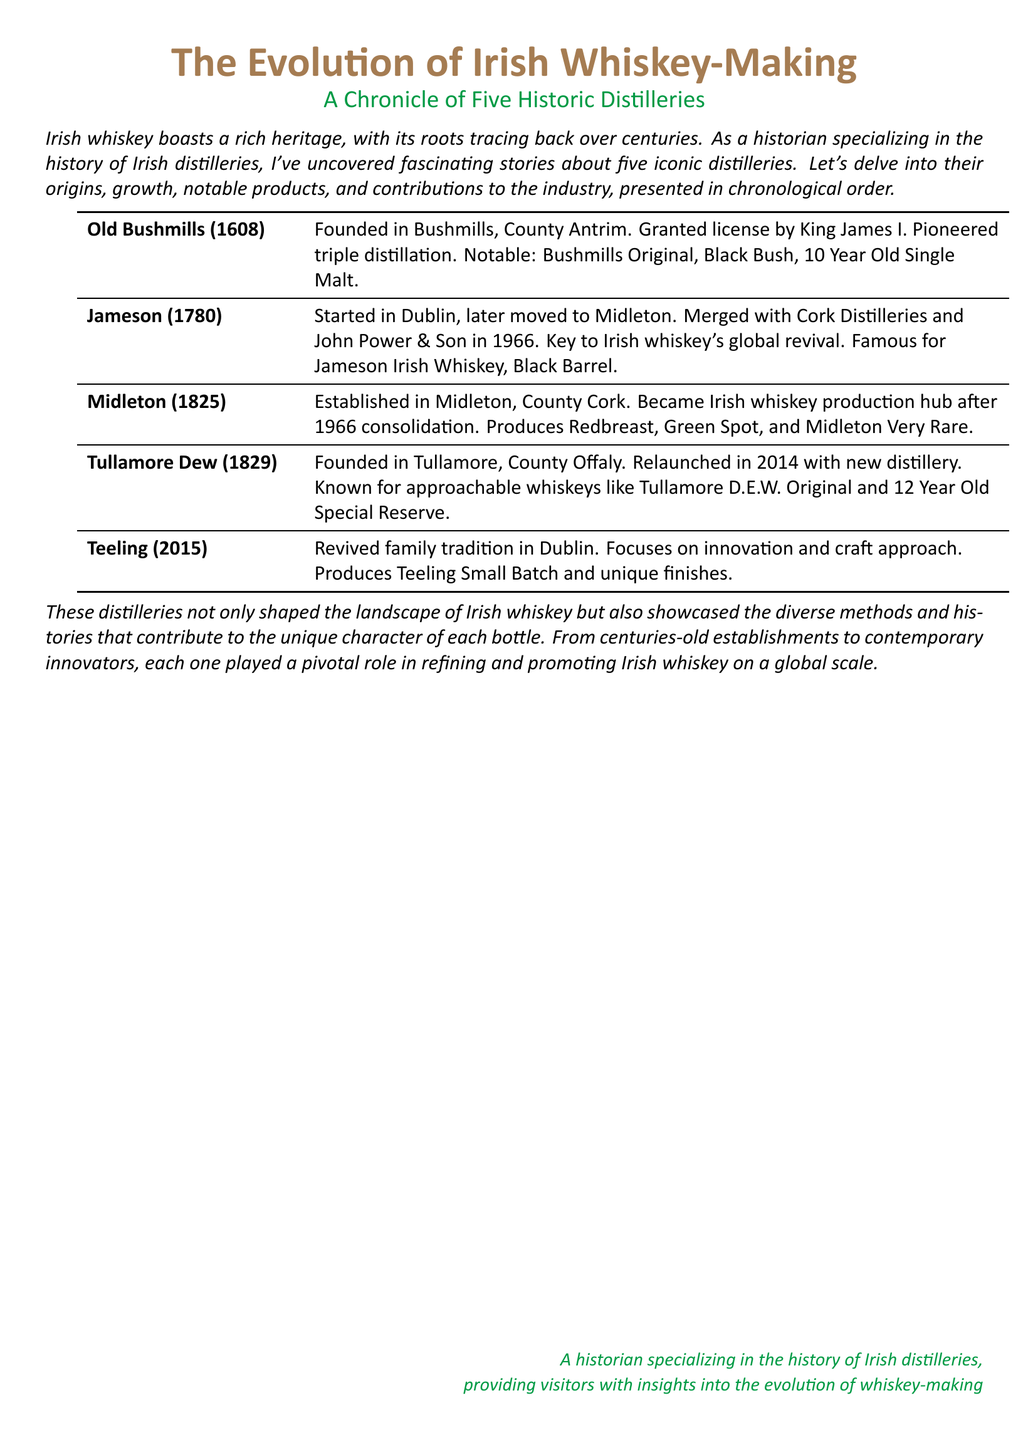What year was Old Bushmills founded? Old Bushmills was founded in the year 1608 as stated in the document.
Answer: 1608 Which distillery is known for the product Black Bush? The document indicates that Black Bush is one of the notable products from Old Bushmills.
Answer: Old Bushmills What year was Jameson established? According to the document, Jameson was established in 1780.
Answer: 1780 What are two notable products from Midleton? The document lists Redbreast and Green Spot as notable products from Midleton.
Answer: Redbreast, Green Spot Which distillery relaunched in 2014? The document mentions Tullamore Dew as the distillery that was relaunched in 2014.
Answer: Tullamore Dew How many years after Old Bushmills was Teeling founded? Teeling was founded in 2015, which is 407 years after Old Bushmills (founded in 1608).
Answer: 407 years What is a key contribution of Jameson to the whiskey industry? The document highlights that Jameson was key to the global revival of Irish whiskey.
Answer: Global revival Which distillery is associated with the town of Tullamore? Tullamore Dew is the distillery connected to the town of Tullamore according to the document.
Answer: Tullamore Dew What approach does Teeling Distillery focus on? The document states that Teeling focuses on innovation and a craft approach.
Answer: Innovation and craft approach 